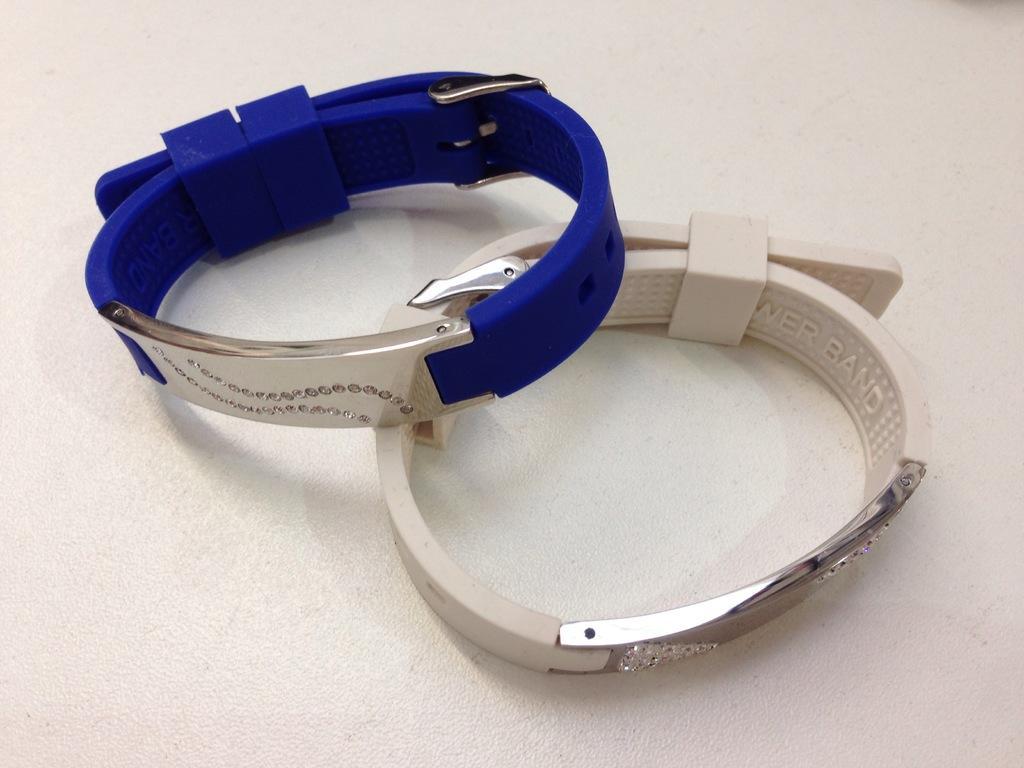How would you summarize this image in a sentence or two? In the image we can see two bands, blue and white in color. And the bands are kept on the white surface. 